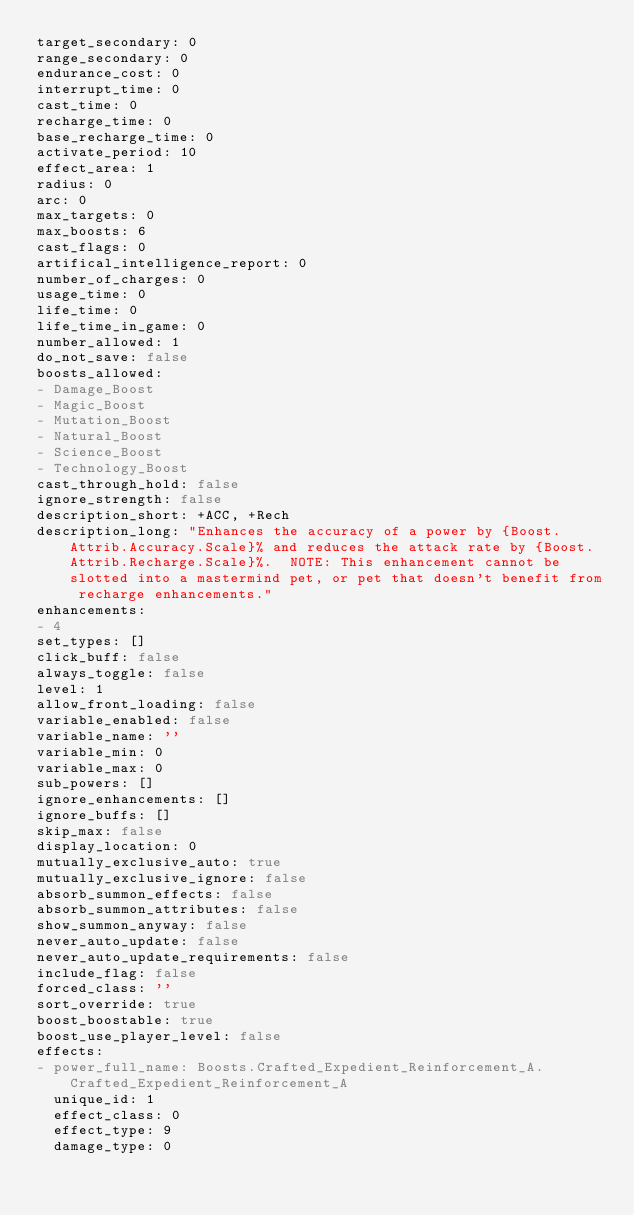Convert code to text. <code><loc_0><loc_0><loc_500><loc_500><_YAML_>target_secondary: 0
range_secondary: 0
endurance_cost: 0
interrupt_time: 0
cast_time: 0
recharge_time: 0
base_recharge_time: 0
activate_period: 10
effect_area: 1
radius: 0
arc: 0
max_targets: 0
max_boosts: 6
cast_flags: 0
artifical_intelligence_report: 0
number_of_charges: 0
usage_time: 0
life_time: 0
life_time_in_game: 0
number_allowed: 1
do_not_save: false
boosts_allowed:
- Damage_Boost
- Magic_Boost
- Mutation_Boost
- Natural_Boost
- Science_Boost
- Technology_Boost
cast_through_hold: false
ignore_strength: false
description_short: +ACC, +Rech
description_long: "Enhances the accuracy of a power by {Boost.Attrib.Accuracy.Scale}% and reduces the attack rate by {Boost.Attrib.Recharge.Scale}%.  NOTE: This enhancement cannot be slotted into a mastermind pet, or pet that doesn't benefit from recharge enhancements."
enhancements:
- 4
set_types: []
click_buff: false
always_toggle: false
level: 1
allow_front_loading: false
variable_enabled: false
variable_name: ''
variable_min: 0
variable_max: 0
sub_powers: []
ignore_enhancements: []
ignore_buffs: []
skip_max: false
display_location: 0
mutually_exclusive_auto: true
mutually_exclusive_ignore: false
absorb_summon_effects: false
absorb_summon_attributes: false
show_summon_anyway: false
never_auto_update: false
never_auto_update_requirements: false
include_flag: false
forced_class: ''
sort_override: true
boost_boostable: true
boost_use_player_level: false
effects:
- power_full_name: Boosts.Crafted_Expedient_Reinforcement_A.Crafted_Expedient_Reinforcement_A
  unique_id: 1
  effect_class: 0
  effect_type: 9
  damage_type: 0</code> 